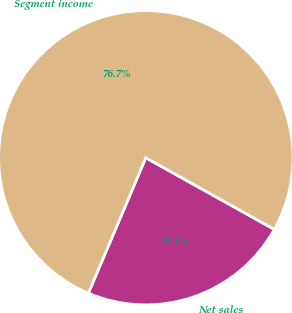Convert chart to OTSL. <chart><loc_0><loc_0><loc_500><loc_500><pie_chart><fcel>Net sales<fcel>Segment income<nl><fcel>23.29%<fcel>76.71%<nl></chart> 